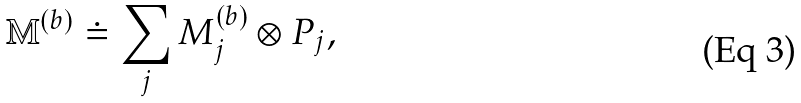Convert formula to latex. <formula><loc_0><loc_0><loc_500><loc_500>\mathbb { M } ^ { ( b ) } \doteq \sum _ { j } { M } _ { j } ^ { ( b ) } \otimes P _ { j } ,</formula> 